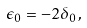<formula> <loc_0><loc_0><loc_500><loc_500>\epsilon _ { 0 } = - 2 \delta _ { 0 } \, ,</formula> 